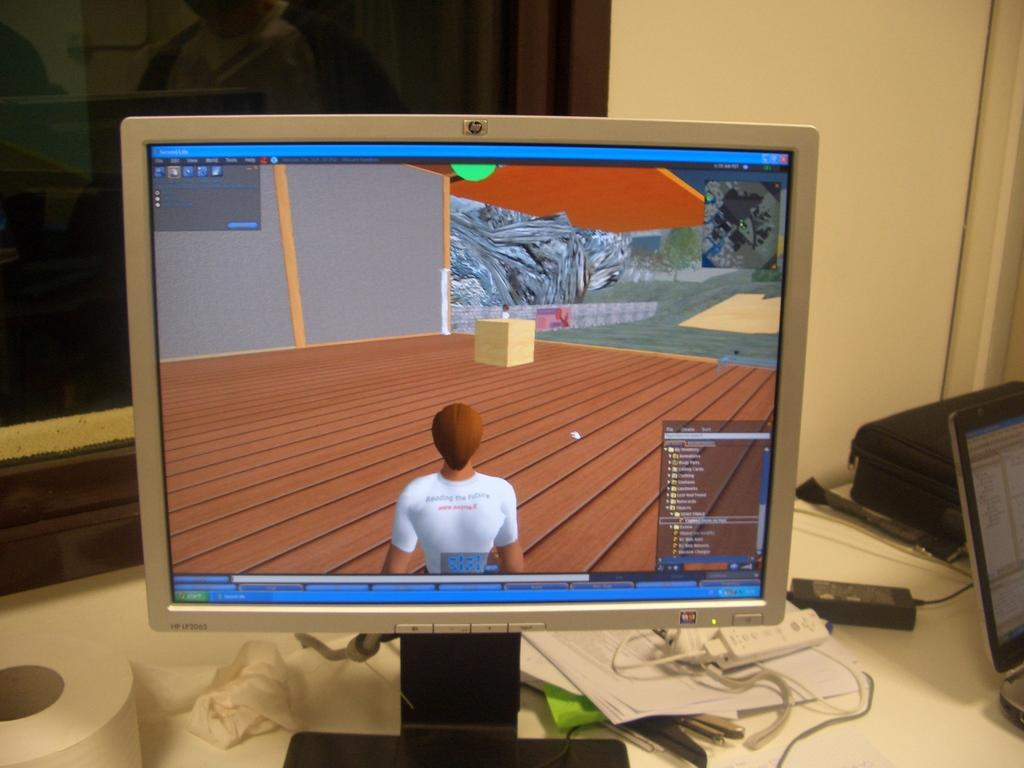<image>
Relay a brief, clear account of the picture shown. An HP computer screen with a game showing a person in a white shirt. 